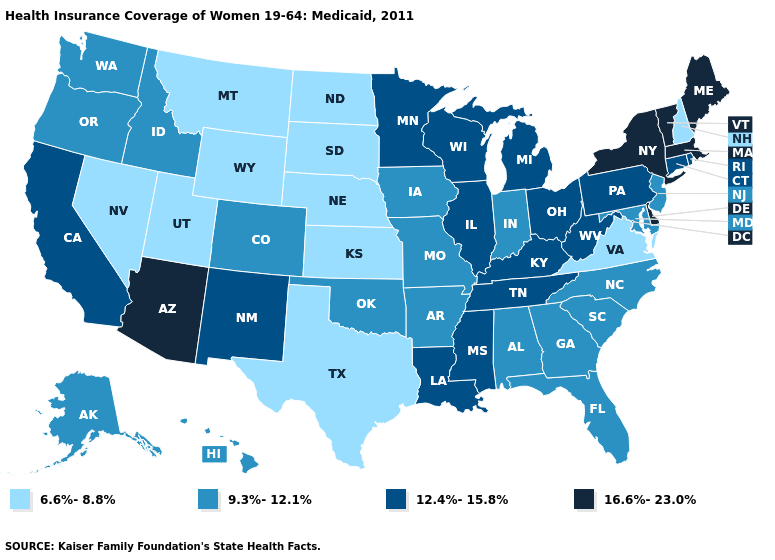How many symbols are there in the legend?
Answer briefly. 4. Is the legend a continuous bar?
Answer briefly. No. Which states hav the highest value in the South?
Give a very brief answer. Delaware. Does the map have missing data?
Give a very brief answer. No. What is the value of Alabama?
Short answer required. 9.3%-12.1%. Does Texas have a lower value than North Dakota?
Be succinct. No. What is the highest value in states that border Montana?
Concise answer only. 9.3%-12.1%. Name the states that have a value in the range 9.3%-12.1%?
Write a very short answer. Alabama, Alaska, Arkansas, Colorado, Florida, Georgia, Hawaii, Idaho, Indiana, Iowa, Maryland, Missouri, New Jersey, North Carolina, Oklahoma, Oregon, South Carolina, Washington. Does Oklahoma have the highest value in the South?
Quick response, please. No. What is the lowest value in the USA?
Short answer required. 6.6%-8.8%. Does Arkansas have a higher value than Kansas?
Short answer required. Yes. How many symbols are there in the legend?
Give a very brief answer. 4. What is the value of Ohio?
Give a very brief answer. 12.4%-15.8%. Name the states that have a value in the range 12.4%-15.8%?
Write a very short answer. California, Connecticut, Illinois, Kentucky, Louisiana, Michigan, Minnesota, Mississippi, New Mexico, Ohio, Pennsylvania, Rhode Island, Tennessee, West Virginia, Wisconsin. What is the lowest value in the MidWest?
Write a very short answer. 6.6%-8.8%. 